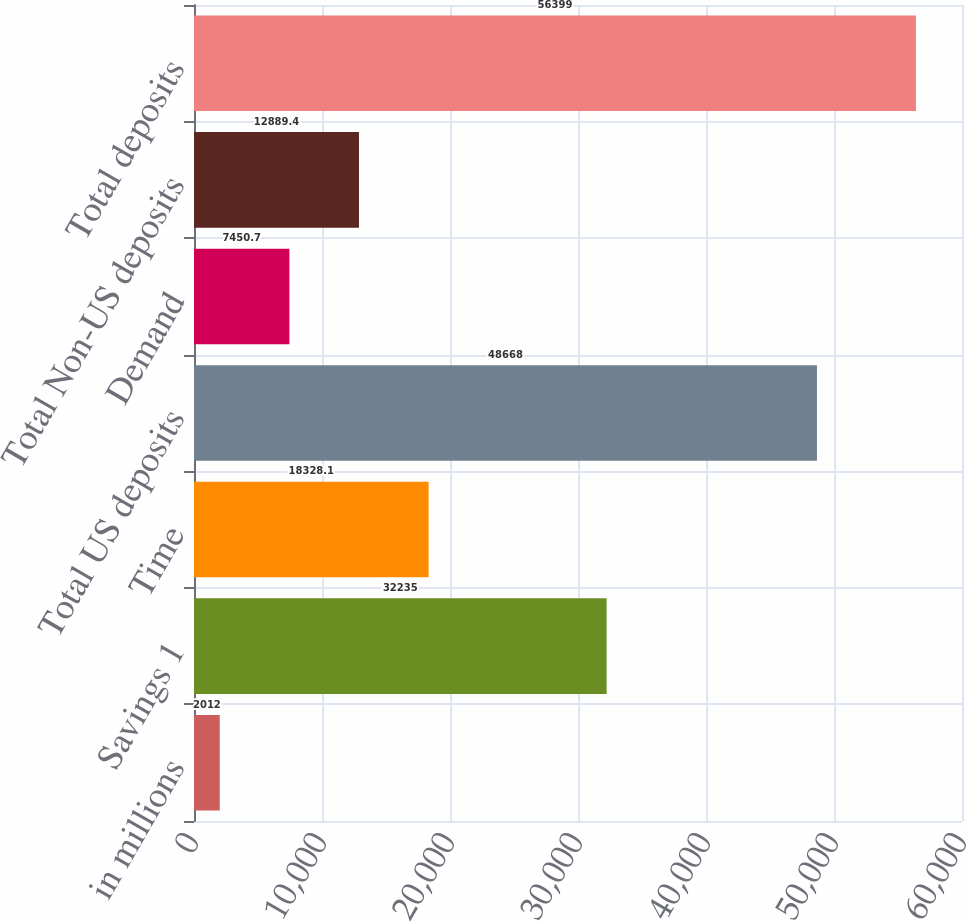<chart> <loc_0><loc_0><loc_500><loc_500><bar_chart><fcel>in millions<fcel>Savings 1<fcel>Time<fcel>Total US deposits<fcel>Demand<fcel>Total Non-US deposits<fcel>Total deposits<nl><fcel>2012<fcel>32235<fcel>18328.1<fcel>48668<fcel>7450.7<fcel>12889.4<fcel>56399<nl></chart> 